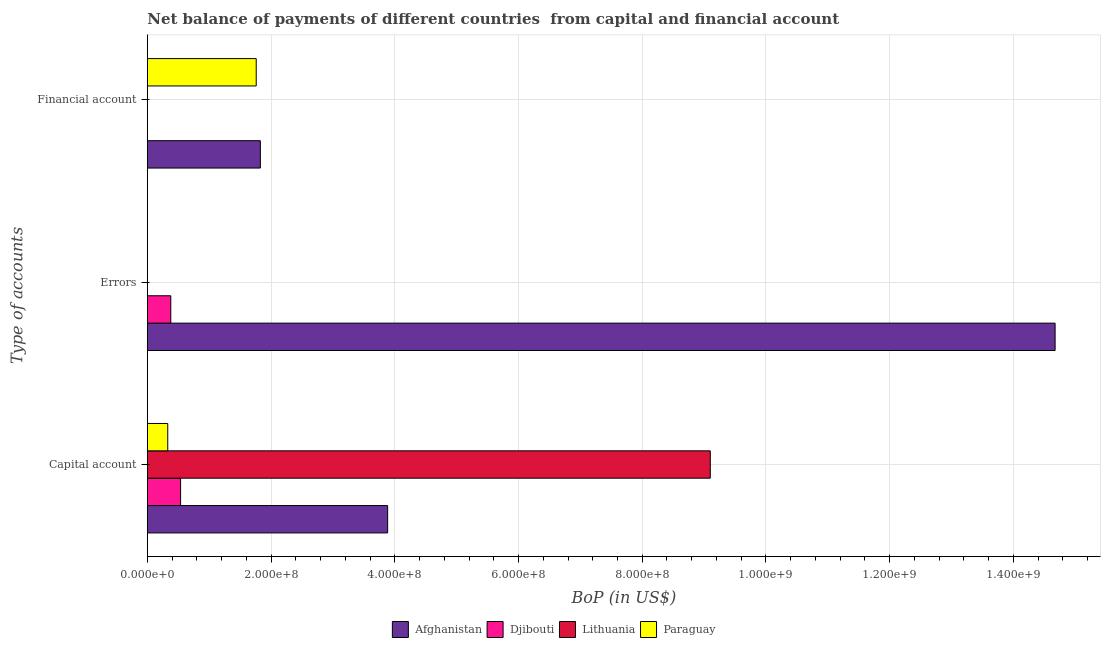How many different coloured bars are there?
Provide a succinct answer. 4. Are the number of bars per tick equal to the number of legend labels?
Give a very brief answer. No. How many bars are there on the 3rd tick from the bottom?
Give a very brief answer. 2. What is the label of the 3rd group of bars from the top?
Your answer should be very brief. Capital account. What is the amount of net capital account in Djibouti?
Provide a succinct answer. 5.37e+07. Across all countries, what is the maximum amount of net capital account?
Your answer should be very brief. 9.10e+08. Across all countries, what is the minimum amount of financial account?
Provide a succinct answer. 0. In which country was the amount of net capital account maximum?
Provide a succinct answer. Lithuania. What is the total amount of net capital account in the graph?
Your response must be concise. 1.39e+09. What is the difference between the amount of net capital account in Lithuania and that in Paraguay?
Make the answer very short. 8.77e+08. What is the difference between the amount of net capital account in Afghanistan and the amount of financial account in Djibouti?
Offer a very short reply. 3.88e+08. What is the average amount of financial account per country?
Offer a terse response. 8.97e+07. What is the difference between the amount of errors and amount of net capital account in Afghanistan?
Your response must be concise. 1.08e+09. In how many countries, is the amount of financial account greater than 1360000000 US$?
Offer a very short reply. 0. What is the ratio of the amount of net capital account in Afghanistan to that in Djibouti?
Keep it short and to the point. 7.23. Is the amount of financial account in Paraguay less than that in Afghanistan?
Keep it short and to the point. Yes. Is the difference between the amount of financial account in Afghanistan and Paraguay greater than the difference between the amount of net capital account in Afghanistan and Paraguay?
Provide a succinct answer. No. What is the difference between the highest and the lowest amount of errors?
Keep it short and to the point. 1.47e+09. In how many countries, is the amount of financial account greater than the average amount of financial account taken over all countries?
Offer a very short reply. 2. Is the sum of the amount of financial account in Afghanistan and Paraguay greater than the maximum amount of errors across all countries?
Your response must be concise. No. Are all the bars in the graph horizontal?
Provide a succinct answer. Yes. What is the difference between two consecutive major ticks on the X-axis?
Provide a succinct answer. 2.00e+08. Are the values on the major ticks of X-axis written in scientific E-notation?
Your response must be concise. Yes. Does the graph contain grids?
Your answer should be very brief. Yes. How many legend labels are there?
Make the answer very short. 4. How are the legend labels stacked?
Provide a succinct answer. Horizontal. What is the title of the graph?
Provide a succinct answer. Net balance of payments of different countries  from capital and financial account. Does "Slovenia" appear as one of the legend labels in the graph?
Your answer should be very brief. No. What is the label or title of the X-axis?
Keep it short and to the point. BoP (in US$). What is the label or title of the Y-axis?
Your response must be concise. Type of accounts. What is the BoP (in US$) of Afghanistan in Capital account?
Ensure brevity in your answer.  3.88e+08. What is the BoP (in US$) in Djibouti in Capital account?
Provide a short and direct response. 5.37e+07. What is the BoP (in US$) in Lithuania in Capital account?
Provide a succinct answer. 9.10e+08. What is the BoP (in US$) of Paraguay in Capital account?
Your answer should be compact. 3.30e+07. What is the BoP (in US$) of Afghanistan in Errors?
Your answer should be very brief. 1.47e+09. What is the BoP (in US$) of Djibouti in Errors?
Provide a short and direct response. 3.79e+07. What is the BoP (in US$) in Lithuania in Errors?
Keep it short and to the point. 0. What is the BoP (in US$) in Afghanistan in Financial account?
Give a very brief answer. 1.83e+08. What is the BoP (in US$) in Djibouti in Financial account?
Keep it short and to the point. 0. What is the BoP (in US$) of Lithuania in Financial account?
Your answer should be very brief. 0. What is the BoP (in US$) in Paraguay in Financial account?
Make the answer very short. 1.76e+08. Across all Type of accounts, what is the maximum BoP (in US$) in Afghanistan?
Give a very brief answer. 1.47e+09. Across all Type of accounts, what is the maximum BoP (in US$) of Djibouti?
Offer a very short reply. 5.37e+07. Across all Type of accounts, what is the maximum BoP (in US$) in Lithuania?
Provide a succinct answer. 9.10e+08. Across all Type of accounts, what is the maximum BoP (in US$) in Paraguay?
Ensure brevity in your answer.  1.76e+08. Across all Type of accounts, what is the minimum BoP (in US$) in Afghanistan?
Your answer should be very brief. 1.83e+08. Across all Type of accounts, what is the minimum BoP (in US$) in Djibouti?
Offer a very short reply. 0. Across all Type of accounts, what is the minimum BoP (in US$) of Lithuania?
Offer a terse response. 0. Across all Type of accounts, what is the minimum BoP (in US$) in Paraguay?
Offer a terse response. 0. What is the total BoP (in US$) in Afghanistan in the graph?
Your response must be concise. 2.04e+09. What is the total BoP (in US$) of Djibouti in the graph?
Keep it short and to the point. 9.16e+07. What is the total BoP (in US$) in Lithuania in the graph?
Offer a terse response. 9.10e+08. What is the total BoP (in US$) of Paraguay in the graph?
Offer a terse response. 2.09e+08. What is the difference between the BoP (in US$) in Afghanistan in Capital account and that in Errors?
Make the answer very short. -1.08e+09. What is the difference between the BoP (in US$) in Djibouti in Capital account and that in Errors?
Provide a succinct answer. 1.58e+07. What is the difference between the BoP (in US$) in Afghanistan in Capital account and that in Financial account?
Provide a succinct answer. 2.06e+08. What is the difference between the BoP (in US$) in Paraguay in Capital account and that in Financial account?
Provide a short and direct response. -1.43e+08. What is the difference between the BoP (in US$) in Afghanistan in Errors and that in Financial account?
Offer a very short reply. 1.28e+09. What is the difference between the BoP (in US$) in Afghanistan in Capital account and the BoP (in US$) in Djibouti in Errors?
Your response must be concise. 3.51e+08. What is the difference between the BoP (in US$) in Afghanistan in Capital account and the BoP (in US$) in Paraguay in Financial account?
Provide a succinct answer. 2.12e+08. What is the difference between the BoP (in US$) of Djibouti in Capital account and the BoP (in US$) of Paraguay in Financial account?
Ensure brevity in your answer.  -1.22e+08. What is the difference between the BoP (in US$) in Lithuania in Capital account and the BoP (in US$) in Paraguay in Financial account?
Provide a short and direct response. 7.34e+08. What is the difference between the BoP (in US$) of Afghanistan in Errors and the BoP (in US$) of Paraguay in Financial account?
Offer a very short reply. 1.29e+09. What is the difference between the BoP (in US$) of Djibouti in Errors and the BoP (in US$) of Paraguay in Financial account?
Offer a terse response. -1.38e+08. What is the average BoP (in US$) of Afghanistan per Type of accounts?
Provide a succinct answer. 6.80e+08. What is the average BoP (in US$) in Djibouti per Type of accounts?
Provide a succinct answer. 3.05e+07. What is the average BoP (in US$) of Lithuania per Type of accounts?
Offer a terse response. 3.03e+08. What is the average BoP (in US$) in Paraguay per Type of accounts?
Your response must be concise. 6.97e+07. What is the difference between the BoP (in US$) of Afghanistan and BoP (in US$) of Djibouti in Capital account?
Provide a short and direct response. 3.35e+08. What is the difference between the BoP (in US$) in Afghanistan and BoP (in US$) in Lithuania in Capital account?
Your response must be concise. -5.22e+08. What is the difference between the BoP (in US$) in Afghanistan and BoP (in US$) in Paraguay in Capital account?
Provide a short and direct response. 3.55e+08. What is the difference between the BoP (in US$) of Djibouti and BoP (in US$) of Lithuania in Capital account?
Offer a very short reply. -8.56e+08. What is the difference between the BoP (in US$) of Djibouti and BoP (in US$) of Paraguay in Capital account?
Make the answer very short. 2.07e+07. What is the difference between the BoP (in US$) in Lithuania and BoP (in US$) in Paraguay in Capital account?
Offer a terse response. 8.77e+08. What is the difference between the BoP (in US$) in Afghanistan and BoP (in US$) in Djibouti in Errors?
Provide a short and direct response. 1.43e+09. What is the difference between the BoP (in US$) of Afghanistan and BoP (in US$) of Paraguay in Financial account?
Provide a short and direct response. 6.69e+06. What is the ratio of the BoP (in US$) in Afghanistan in Capital account to that in Errors?
Make the answer very short. 0.26. What is the ratio of the BoP (in US$) in Djibouti in Capital account to that in Errors?
Your answer should be very brief. 1.42. What is the ratio of the BoP (in US$) of Afghanistan in Capital account to that in Financial account?
Ensure brevity in your answer.  2.13. What is the ratio of the BoP (in US$) of Paraguay in Capital account to that in Financial account?
Keep it short and to the point. 0.19. What is the ratio of the BoP (in US$) in Afghanistan in Errors to that in Financial account?
Your response must be concise. 8.03. What is the difference between the highest and the second highest BoP (in US$) in Afghanistan?
Offer a very short reply. 1.08e+09. What is the difference between the highest and the lowest BoP (in US$) in Afghanistan?
Keep it short and to the point. 1.28e+09. What is the difference between the highest and the lowest BoP (in US$) in Djibouti?
Your answer should be compact. 5.37e+07. What is the difference between the highest and the lowest BoP (in US$) in Lithuania?
Provide a succinct answer. 9.10e+08. What is the difference between the highest and the lowest BoP (in US$) in Paraguay?
Your answer should be compact. 1.76e+08. 